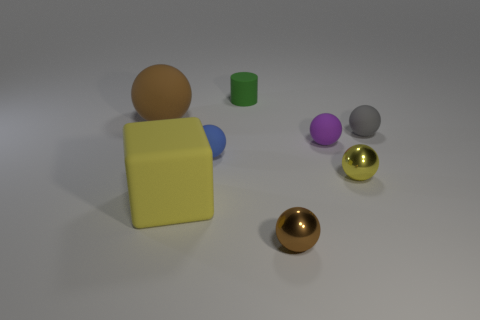There is a ball that is the same color as the rubber block; what size is it?
Provide a succinct answer. Small. What color is the big thing that is in front of the big object that is left of the large rubber thing in front of the big brown matte thing?
Your response must be concise. Yellow. What is the color of the other tiny metal object that is the same shape as the small brown metallic thing?
Offer a terse response. Yellow. Is there anything else that has the same color as the large block?
Provide a succinct answer. Yes. What number of other objects are the same material as the small yellow sphere?
Offer a terse response. 1. The matte cube has what size?
Keep it short and to the point. Large. Are there any tiny brown objects that have the same shape as the tiny purple object?
Make the answer very short. Yes. How many objects are gray spheres or brown spheres that are behind the yellow metallic sphere?
Keep it short and to the point. 2. There is a big thing that is behind the tiny gray rubber ball; what is its color?
Your answer should be compact. Brown. Does the rubber block that is on the right side of the large brown rubber thing have the same size as the brown sphere on the right side of the big brown matte thing?
Provide a short and direct response. No. 